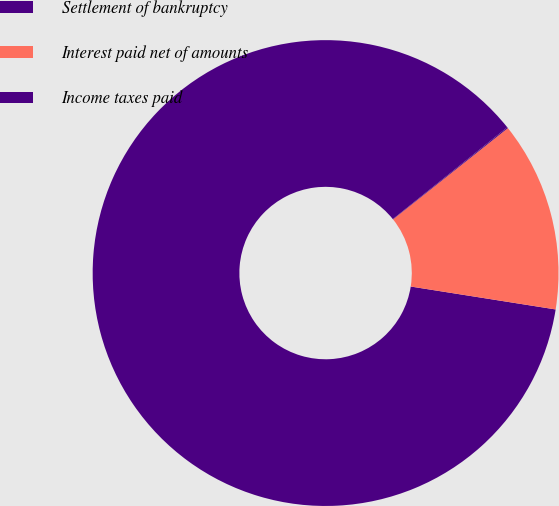Convert chart. <chart><loc_0><loc_0><loc_500><loc_500><pie_chart><fcel>Settlement of bankruptcy<fcel>Interest paid net of amounts<fcel>Income taxes paid<nl><fcel>86.75%<fcel>13.19%<fcel>0.07%<nl></chart> 